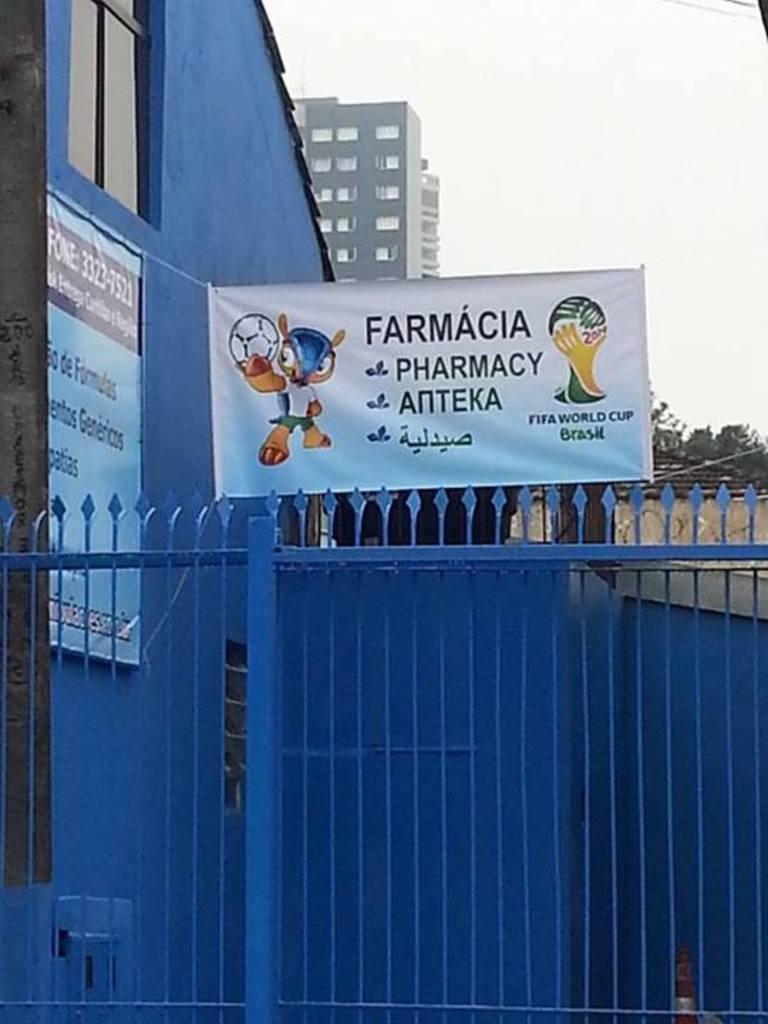<image>
Describe the image concisely. A blue fence and a sign reading pharmacy on top of it. 